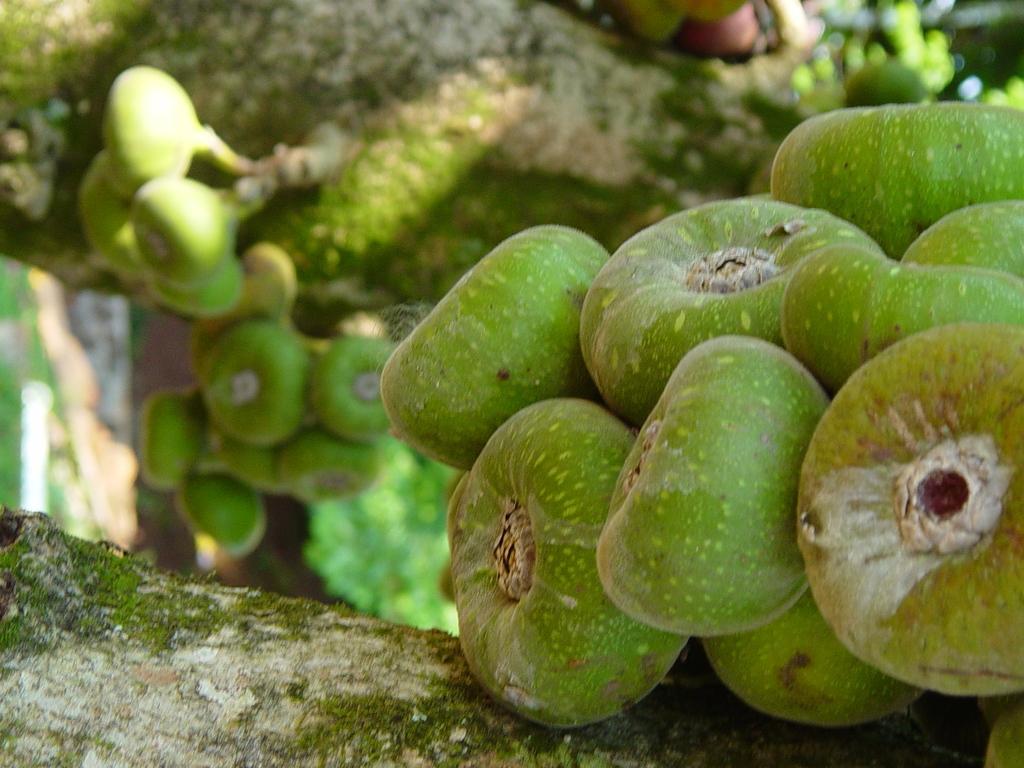Can you describe this image briefly? In this picture we can see a tree, we can see some fruits here. 